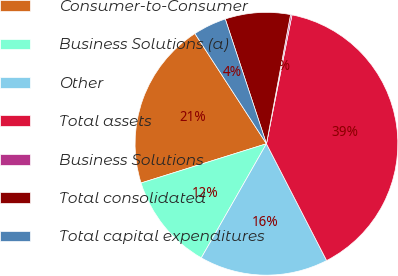Convert chart. <chart><loc_0><loc_0><loc_500><loc_500><pie_chart><fcel>Consumer-to-Consumer<fcel>Business Solutions (a)<fcel>Other<fcel>Total assets<fcel>Business Solutions<fcel>Total consolidated<fcel>Total capital expenditures<nl><fcel>20.66%<fcel>11.92%<fcel>15.83%<fcel>39.31%<fcel>0.18%<fcel>8.01%<fcel>4.09%<nl></chart> 